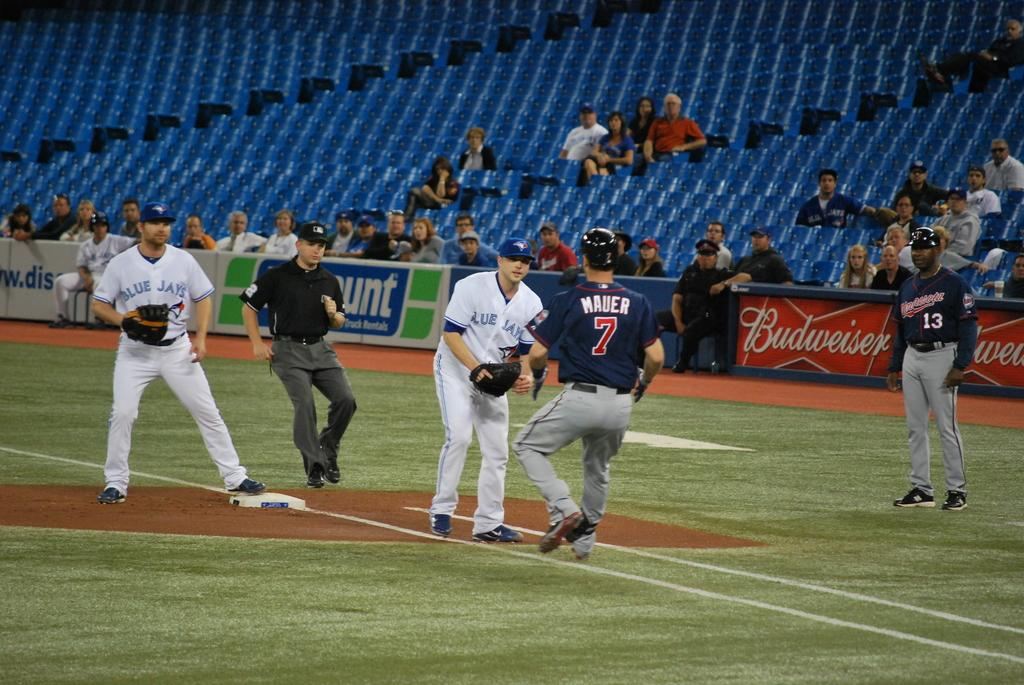<image>
Render a clear and concise summary of the photo. The Blue Jays try to get a man out at base during sparsely attened baseball game. 